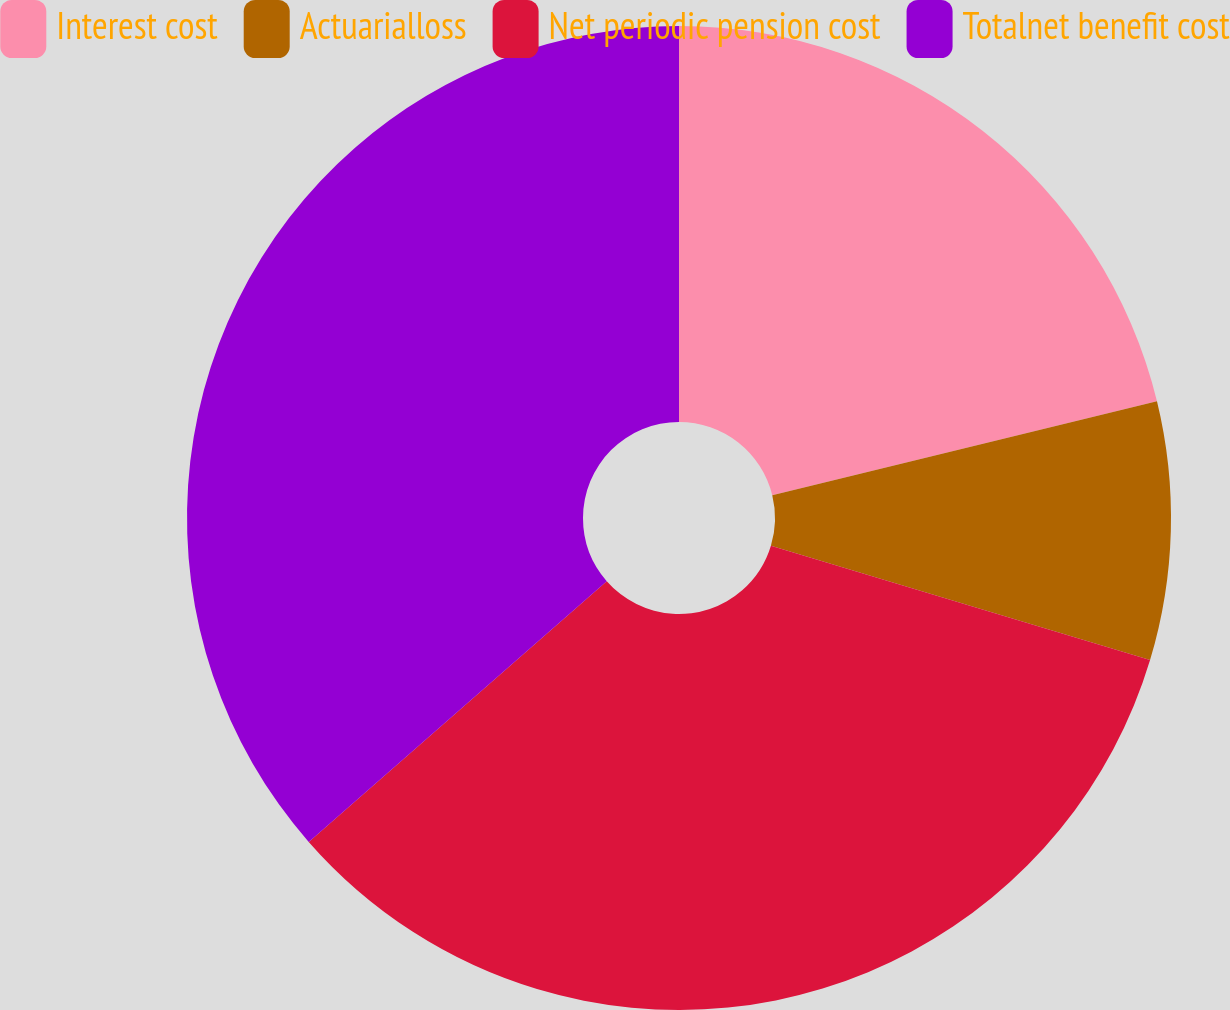<chart> <loc_0><loc_0><loc_500><loc_500><pie_chart><fcel>Interest cost<fcel>Actuarialloss<fcel>Net periodic pension cost<fcel>Totalnet benefit cost<nl><fcel>21.19%<fcel>8.47%<fcel>33.9%<fcel>36.44%<nl></chart> 